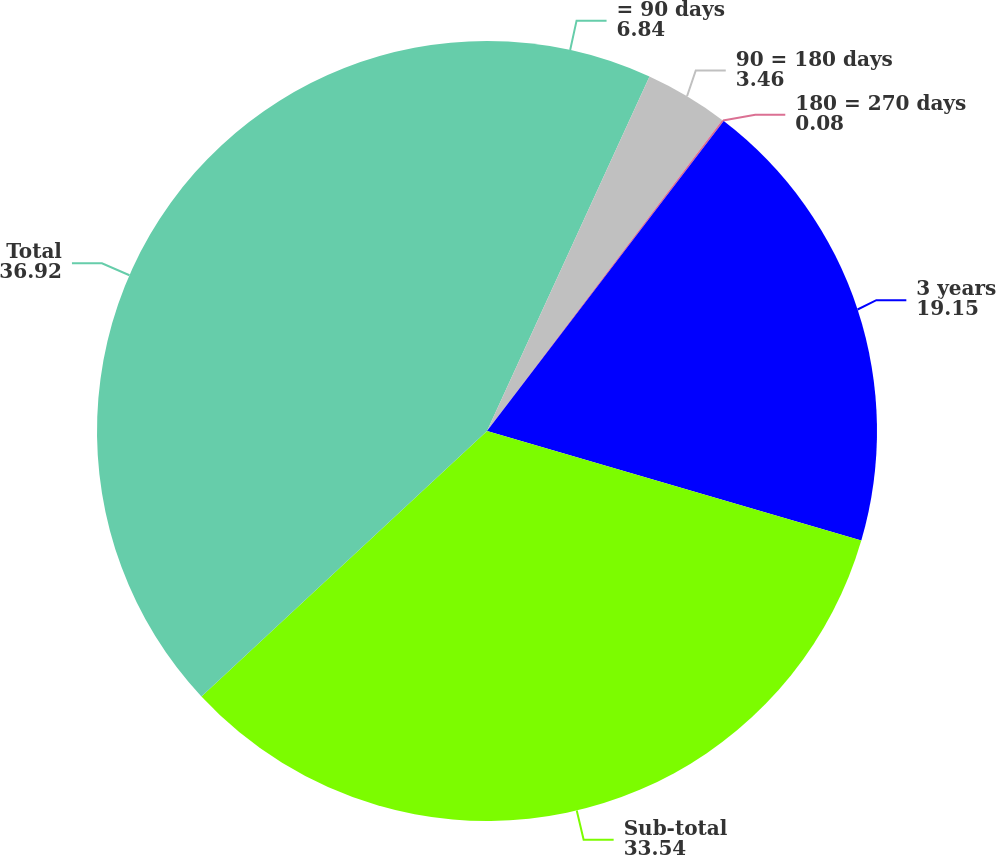Convert chart to OTSL. <chart><loc_0><loc_0><loc_500><loc_500><pie_chart><fcel>= 90 days<fcel>90 = 180 days<fcel>180 = 270 days<fcel>3 years<fcel>Sub-total<fcel>Total<nl><fcel>6.84%<fcel>3.46%<fcel>0.08%<fcel>19.15%<fcel>33.54%<fcel>36.92%<nl></chart> 